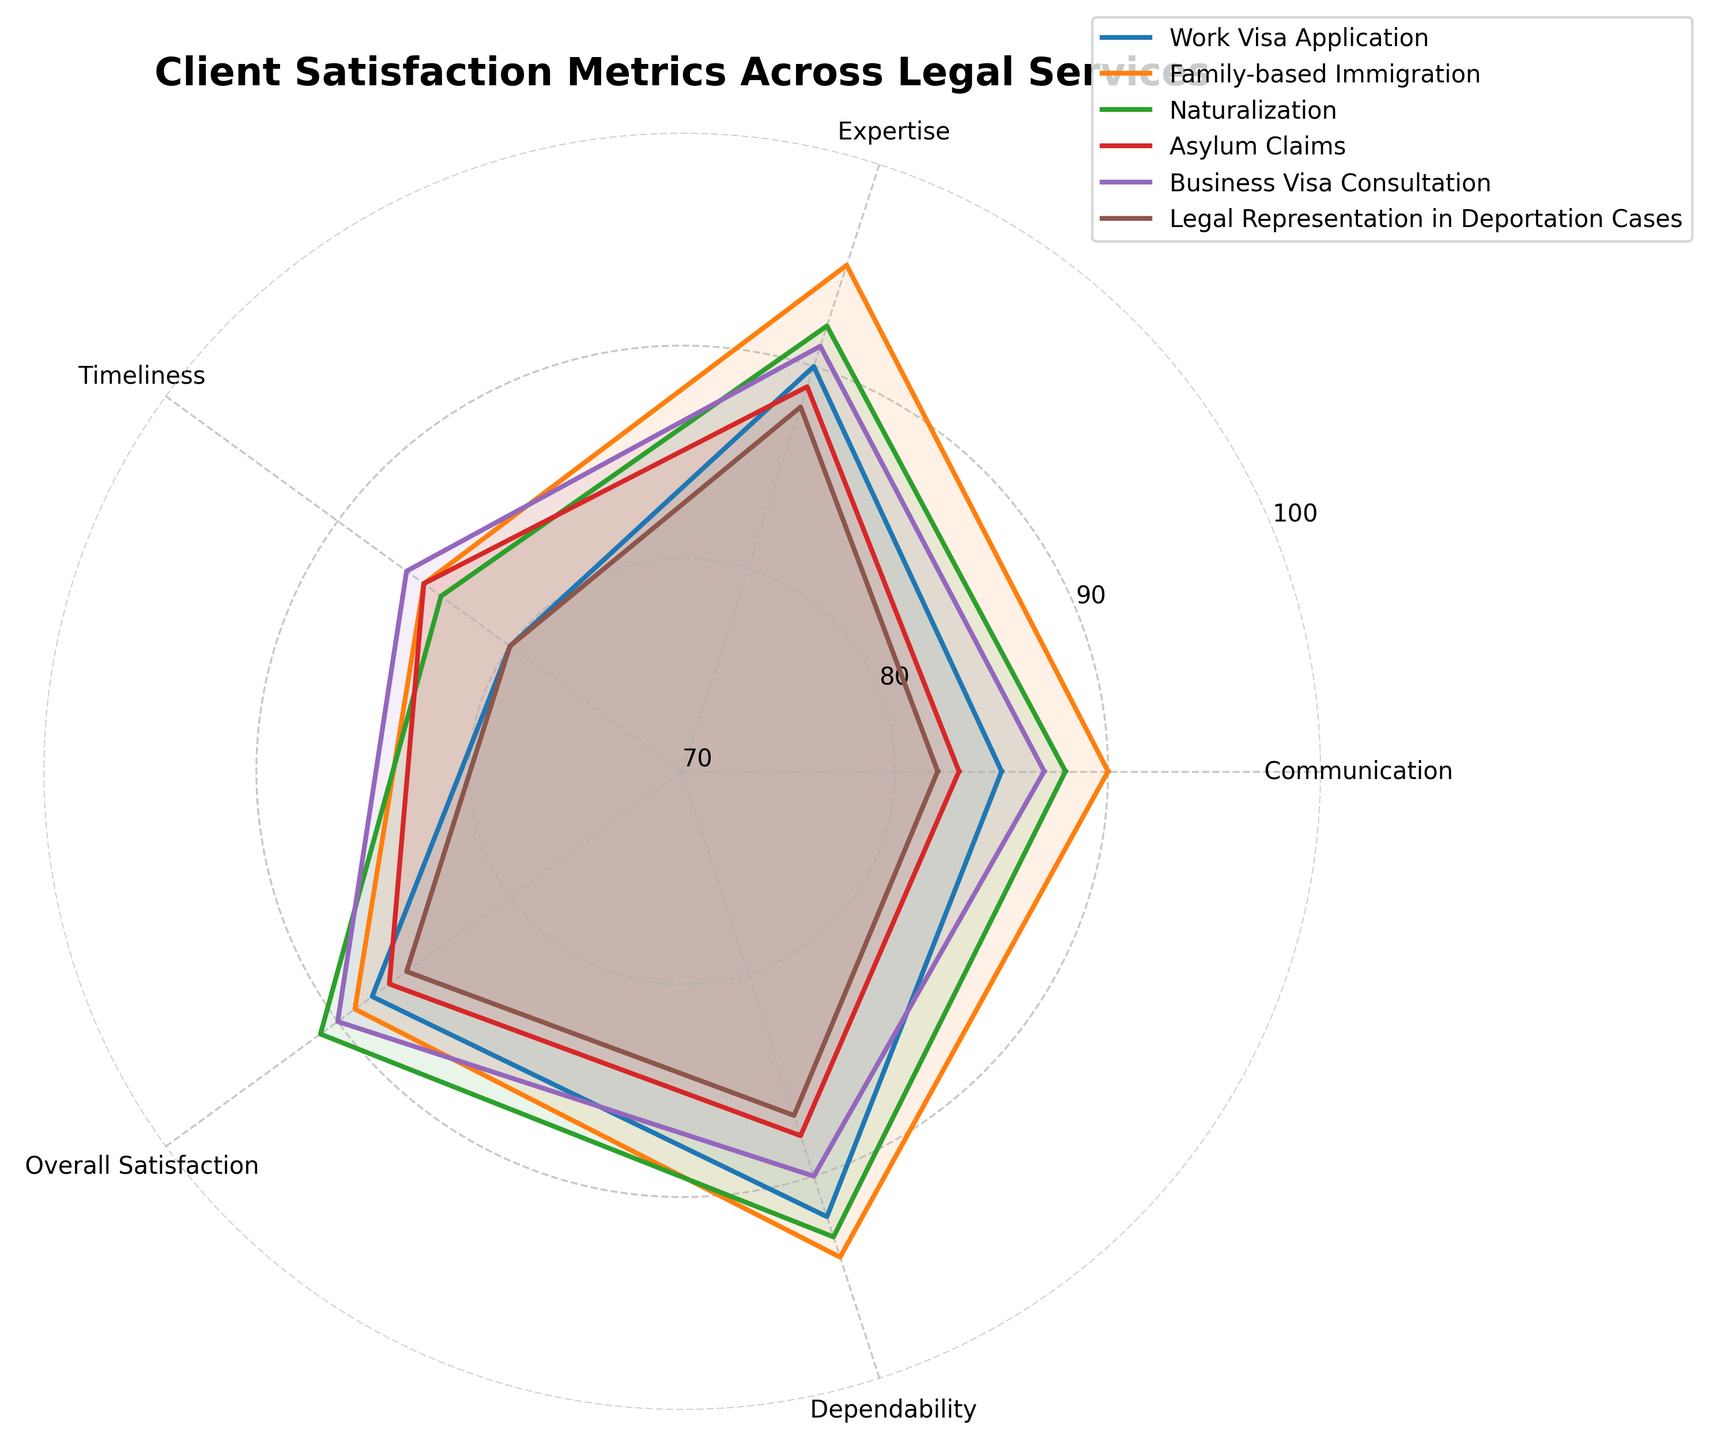What is the highest score for Communication across all services? Look at the Communication values for all services (85, 90, 88, 83, 87, 82) and identify the highest one
Answer: 90 Which service has the lowest overall satisfaction? Review the Overall Satisfaction scores (88, 89, 91, 87, 90, 86), and identify which service has the lowest value, which is 86. This corresponds to the Legal Representation in Deportation Cases.
Answer: Legal Representation in Deportation Cases What is the average Expertise score across all services? Sum up all Expertise scores (90, 95, 92, 89, 91, 88) = 545, and then divide by the number of services (6). Thus, the average is 545/6 ≈ 90.83
Answer: 90.83 Which service provides the most dependable service based on client satisfaction scores? Compare Dependability scores (92, 94, 93, 88, 90, 87), and the highest score is 94. This corresponds to the Family-based Immigration service
Answer: Family-based Immigration How does the Timeliness of work visa applications compare to that of naturalizations? Look at the Timeliness scores: Work Visa Application has 80, Naturalization has 84. By comparison, 80 < 84.
Answer: Naturalization has better Timeliness than Work Visa Application Which service received the most consistent scores across all categories? Examine the variability of scores within each service:
- Work Visa Application: (85, 90, 80, 88, 92)
- Family-based Immigration: (90, 95, 85, 89, 94)
- Naturalization: (88, 92, 84, 91, 93)
- Asylum Claims: (83, 89, 85, 87, 88)
- Business Visa Consultation: (87, 91, 86, 90, 90)
- Legal Representation in Deportation Cases: (82, 88, 80, 86, 87)
Business Visa Consultation has the most consistent (least variable) scores.
Answer: Business Visa Consultation For which service is client satisfaction with Communication and Expertise equally scored? Review the scores for Communication and Expertise: (Work Visa Application 85-90, Family-based Immigration 90-95, Naturalization 88-92, Asylum Claims 83-89, Business Visa Consultation 87-91, Legal Representation in Deportation Cases 82-88). There is no service with identical scores for both categories.
Answer: None 